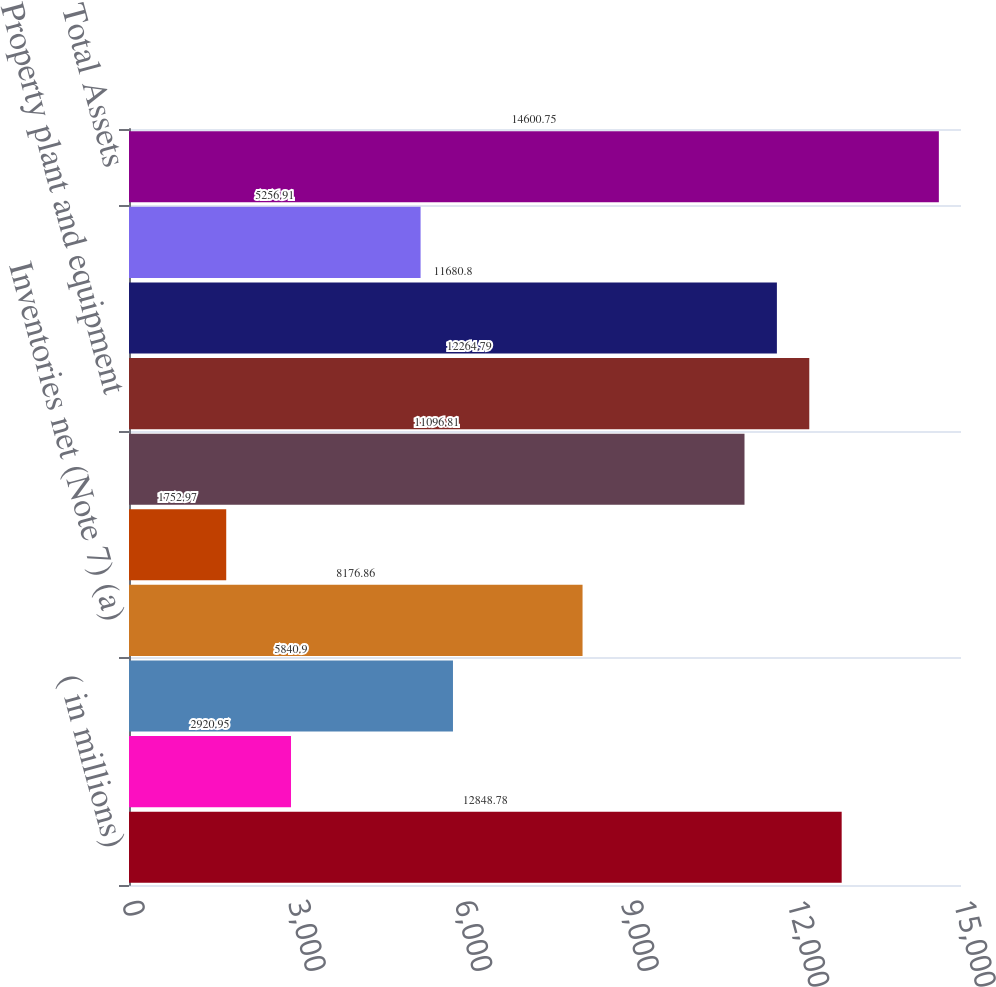Convert chart. <chart><loc_0><loc_0><loc_500><loc_500><bar_chart><fcel>( in millions)<fcel>Cash and cash equivalents<fcel>Receivables net (Note 6)<fcel>Inventories net (Note 7) (a)<fcel>Deferred taxes and prepaid<fcel>Total current assets<fcel>Property plant and equipment<fcel>Goodwill (Notes 3 4 and 9)<fcel>Intangibles and other assets<fcel>Total Assets<nl><fcel>12848.8<fcel>2920.95<fcel>5840.9<fcel>8176.86<fcel>1752.97<fcel>11096.8<fcel>12264.8<fcel>11680.8<fcel>5256.91<fcel>14600.8<nl></chart> 